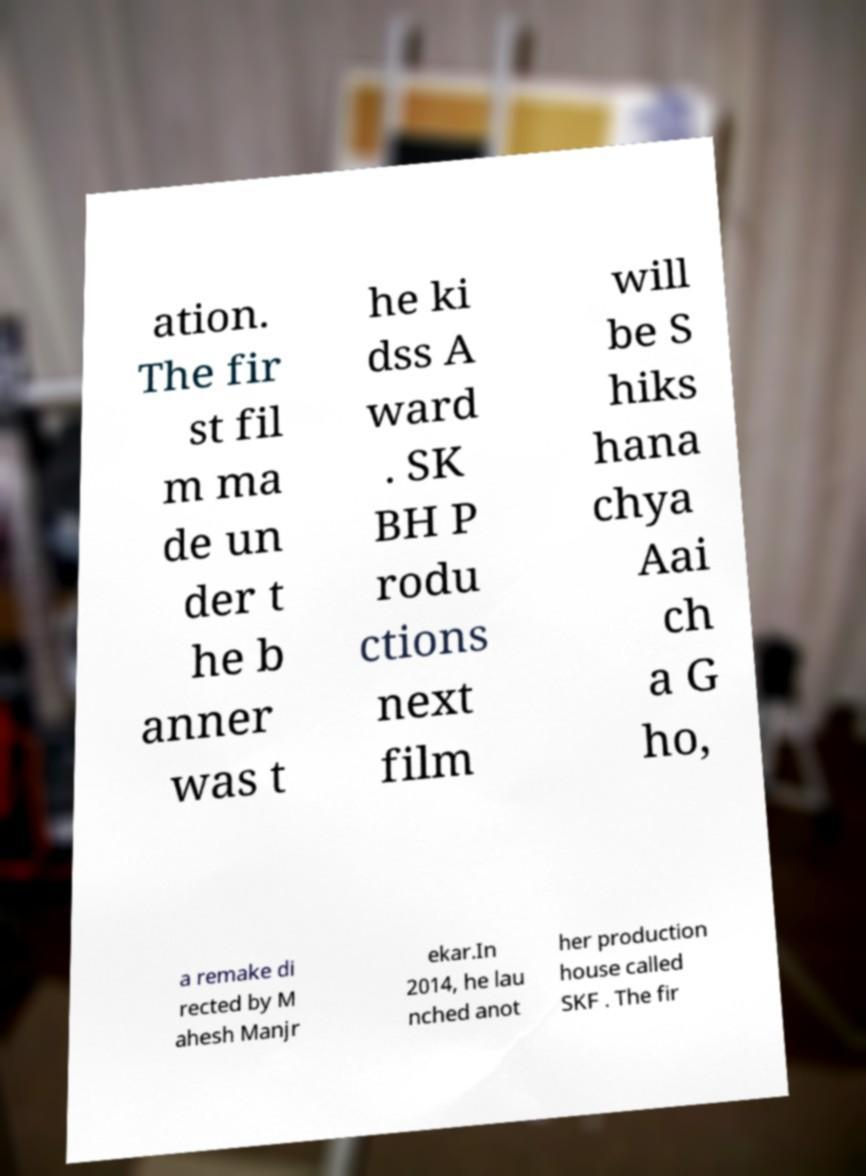There's text embedded in this image that I need extracted. Can you transcribe it verbatim? ation. The fir st fil m ma de un der t he b anner was t he ki dss A ward . SK BH P rodu ctions next film will be S hiks hana chya Aai ch a G ho, a remake di rected by M ahesh Manjr ekar.In 2014, he lau nched anot her production house called SKF . The fir 